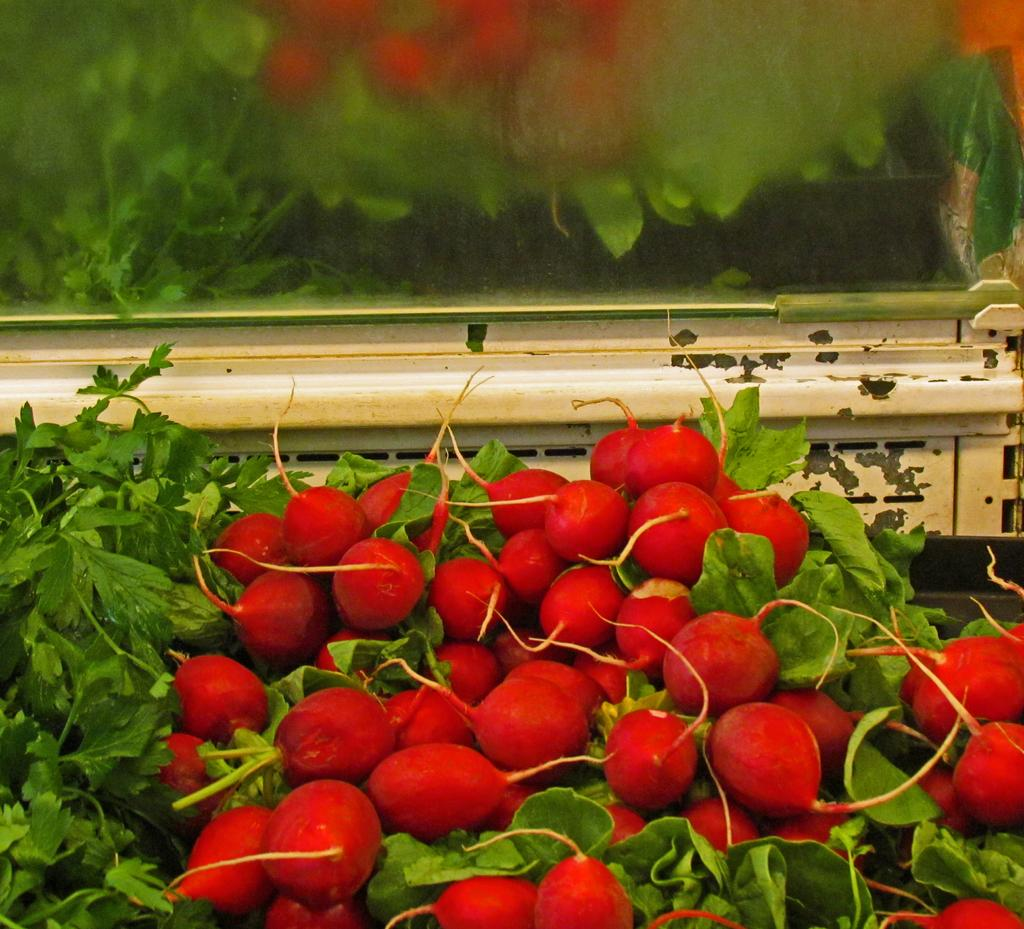What is located at the bottom of the image? There are fruits and leaves at the bottom of the image. What can be seen in the background of the image? There appears to be a glass mirror in the background of the image. What is reflected in the mirror? There is a reflection of fruits and plants in the mirror. What type of steel is used to create the mint leaves in the image? There are no steel or mint leaves present in the image; it features fruits and leaves made of plant material. 